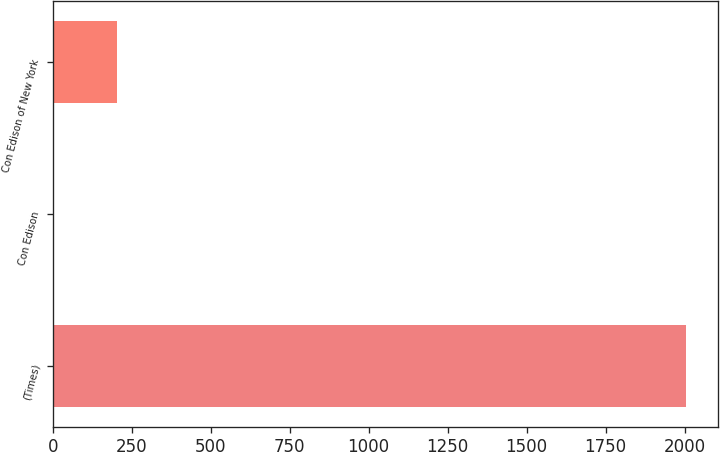Convert chart to OTSL. <chart><loc_0><loc_0><loc_500><loc_500><bar_chart><fcel>(Times)<fcel>Con Edison<fcel>Con Edison of New York<nl><fcel>2006<fcel>2.9<fcel>203.21<nl></chart> 